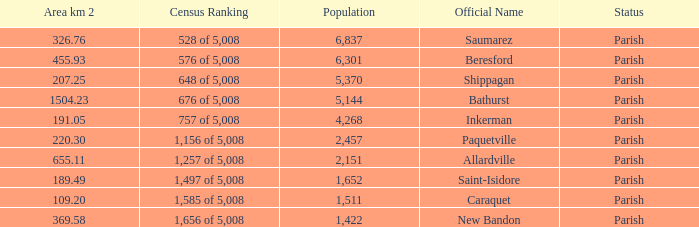What is the Area of the Allardville Parish with a Population smaller than 2,151? None. 